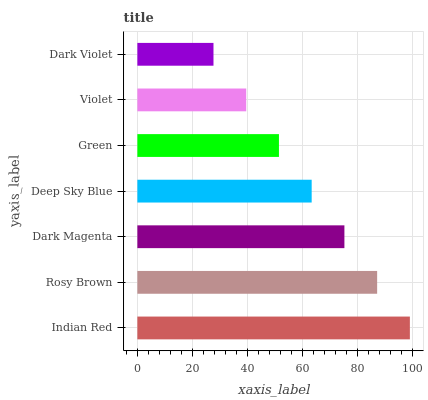Is Dark Violet the minimum?
Answer yes or no. Yes. Is Indian Red the maximum?
Answer yes or no. Yes. Is Rosy Brown the minimum?
Answer yes or no. No. Is Rosy Brown the maximum?
Answer yes or no. No. Is Indian Red greater than Rosy Brown?
Answer yes or no. Yes. Is Rosy Brown less than Indian Red?
Answer yes or no. Yes. Is Rosy Brown greater than Indian Red?
Answer yes or no. No. Is Indian Red less than Rosy Brown?
Answer yes or no. No. Is Deep Sky Blue the high median?
Answer yes or no. Yes. Is Deep Sky Blue the low median?
Answer yes or no. Yes. Is Indian Red the high median?
Answer yes or no. No. Is Indian Red the low median?
Answer yes or no. No. 